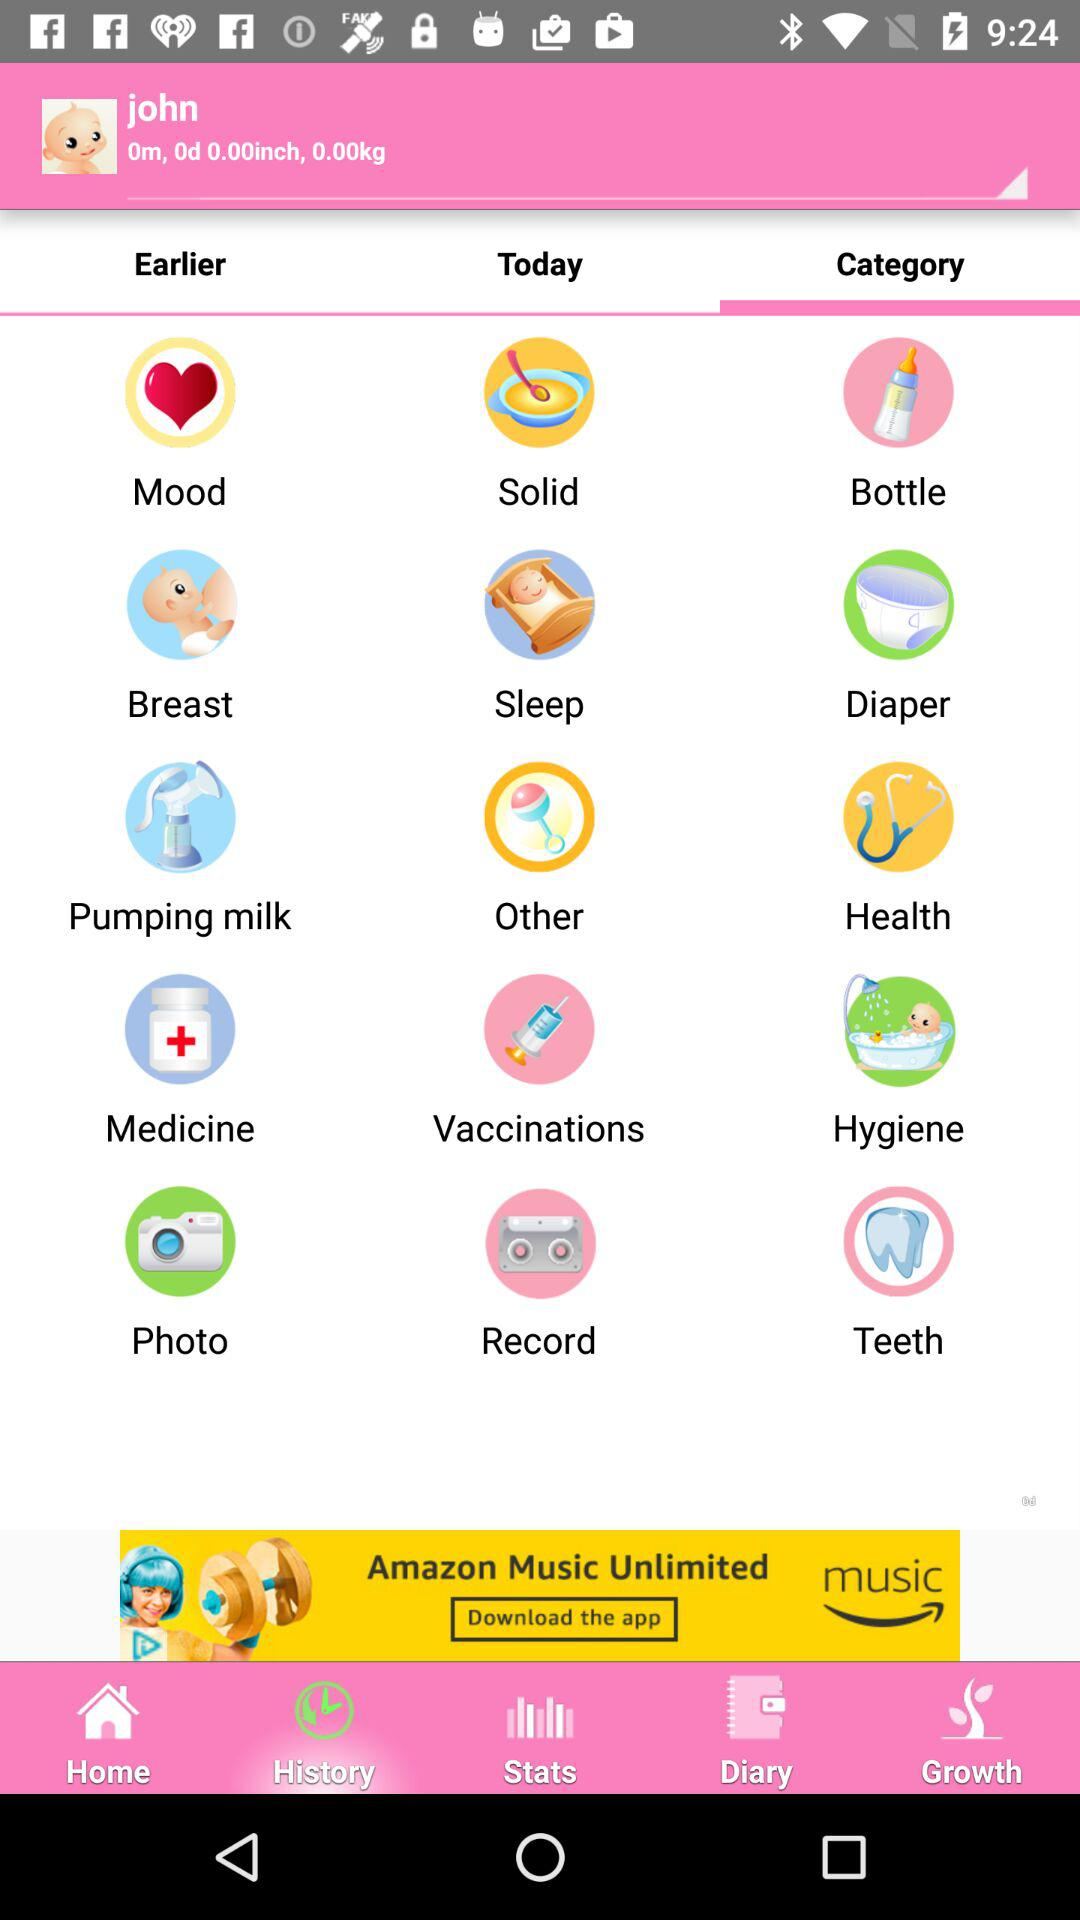What is the height of the baby? The height of the baby is 0 inches. 